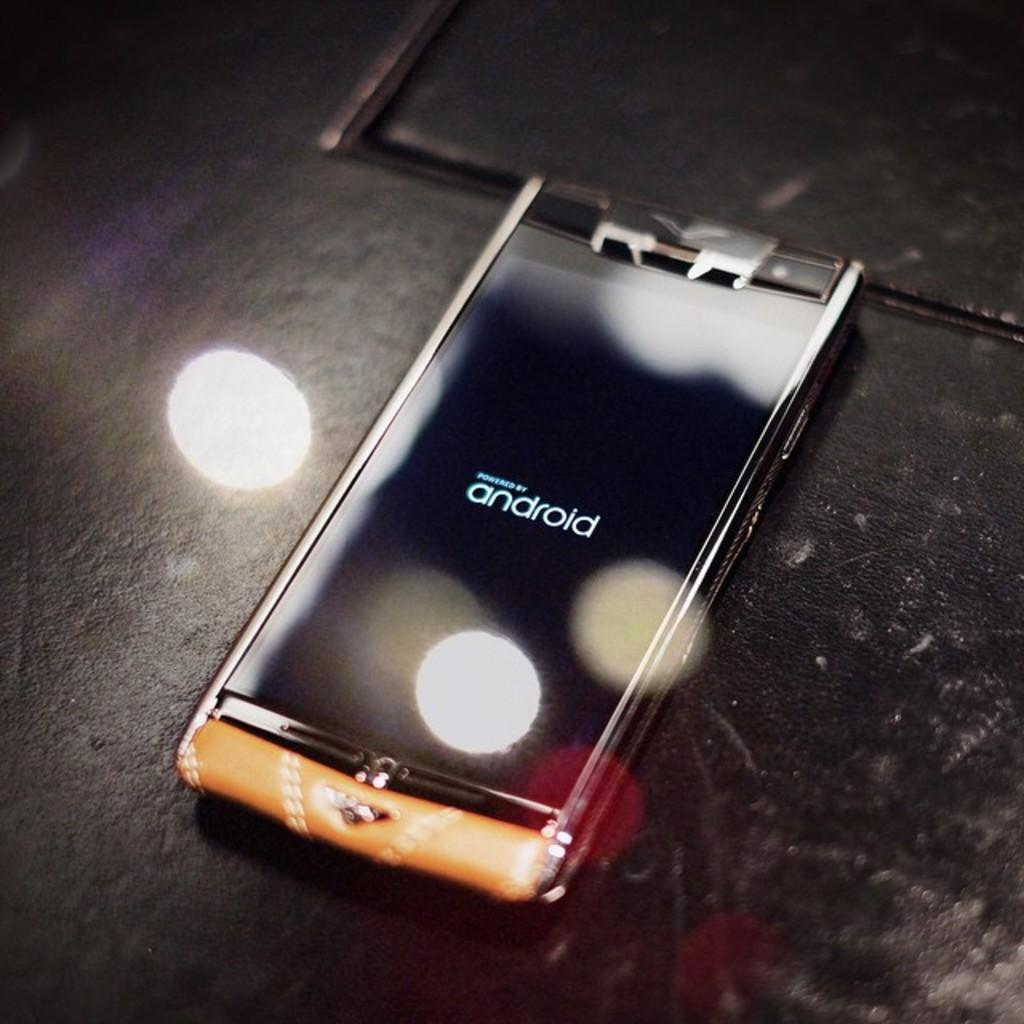Provide a one-sentence caption for the provided image. A phone screen indicates that it is powered by Android. 